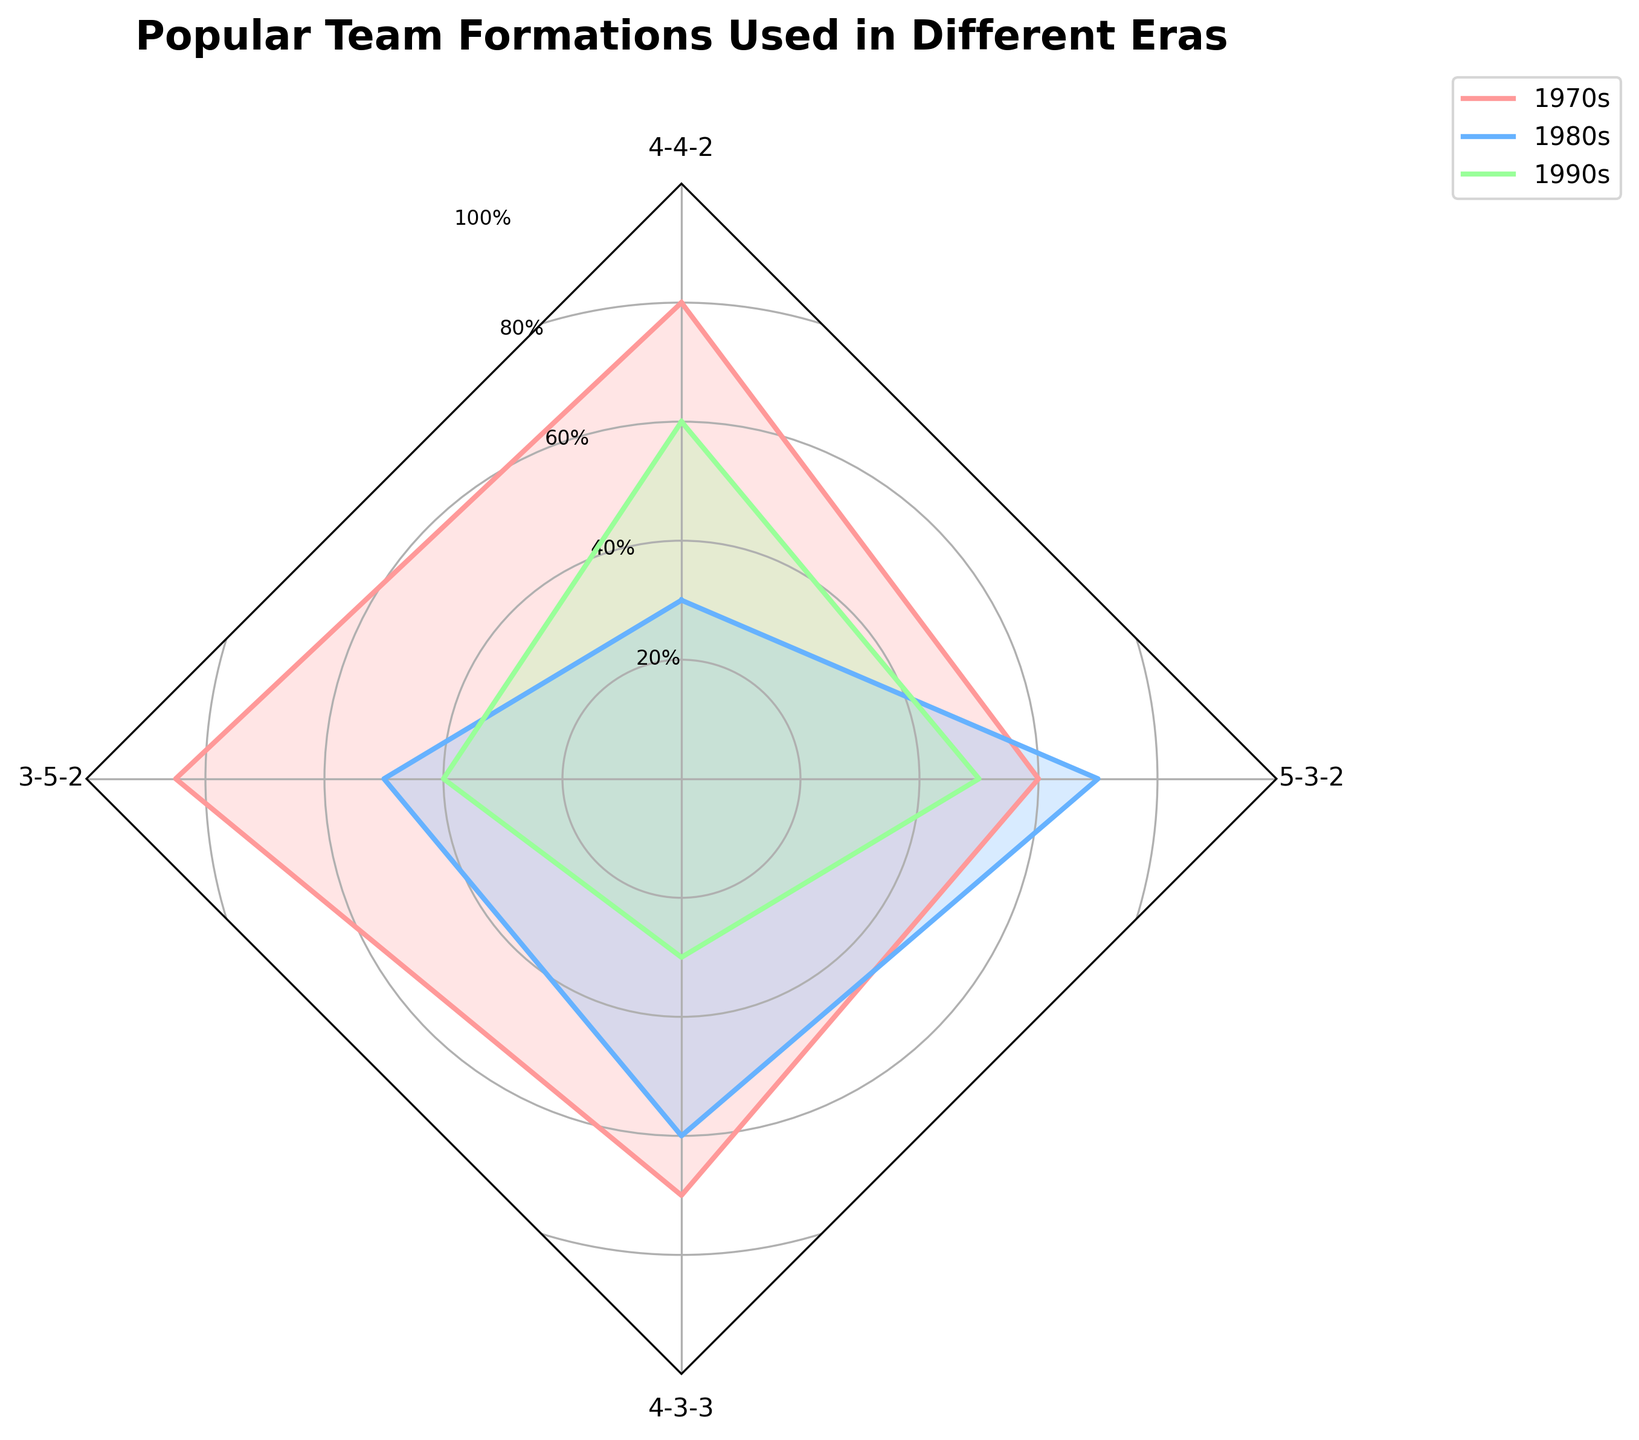Which era shows the highest popularity for the 4-3-3 formation? To determine the era where the 4-3-3 formation was most popular, examine the chart and see which era has the largest value for this formation. In this case, the 1970s has the highest value for the 4-3-3 formation at 60%.
Answer: 1970s Which formation's popularity increased the most between the 1970s and 2000s? To see which formation's popularity increased the most, calculate the difference in popularity for each formation between the 1970s and 2000s. The formation with the largest positive difference is 3-5-2, which increases from 30% to 70%.
Answer: 3-5-2 What's the overall trend of the 4-4-2 formation from the 1970s to the 2000s? Observing the data points for the 4-4-2 formation across the decades shows a decline in popularity: from 80% in the 1970s to 85% in the 1980s, 70% in the 1990s, and 60% in the 2000s. Therefore, the overall trend is decreasing.
Answer: Decreasing Among the three formations shown (4-4-2, 3-5-2, 4-3-3), which formation was least popular in the 1980s? Compare the values for the 1980s for the formations 4-4-2, 3-5-2, and 4-3-3. The least popular formation is 4-3-3 with a value of 40%.
Answer: 4-3-3 Which era had the highest average popularity across all shown formations (4-4-2, 3-5-2, 4-3-3)? To find the highest average popularity, calculate the average for each era: 
1970s: (80+30+60)/3 = 56.67, 
1980s: (85+50+40)/3 = 58.33, 
1990s: (70+60+30)/3 = 53.33, 
2000s: (60+70+50)/3 = 60. Thus, the 2000s had the highest average popularity.
Answer: 2000s 